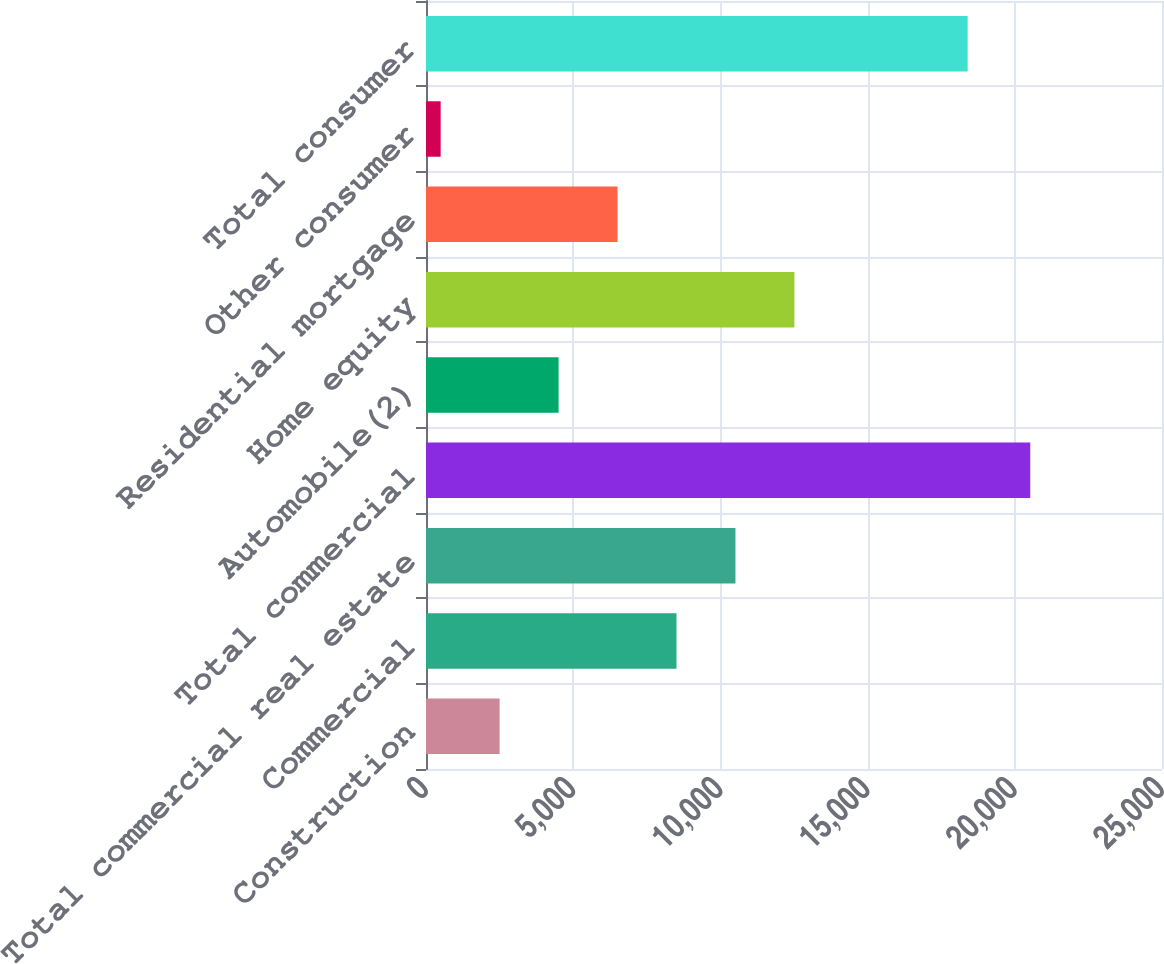Convert chart. <chart><loc_0><loc_0><loc_500><loc_500><bar_chart><fcel>Construction<fcel>Commercial<fcel>Total commercial real estate<fcel>Total commercial<fcel>Automobile(2)<fcel>Home equity<fcel>Residential mortgage<fcel>Other consumer<fcel>Total consumer<nl><fcel>2500.7<fcel>8508.8<fcel>10511.5<fcel>20525<fcel>4503.4<fcel>12514.2<fcel>6506.1<fcel>498<fcel>18399<nl></chart> 